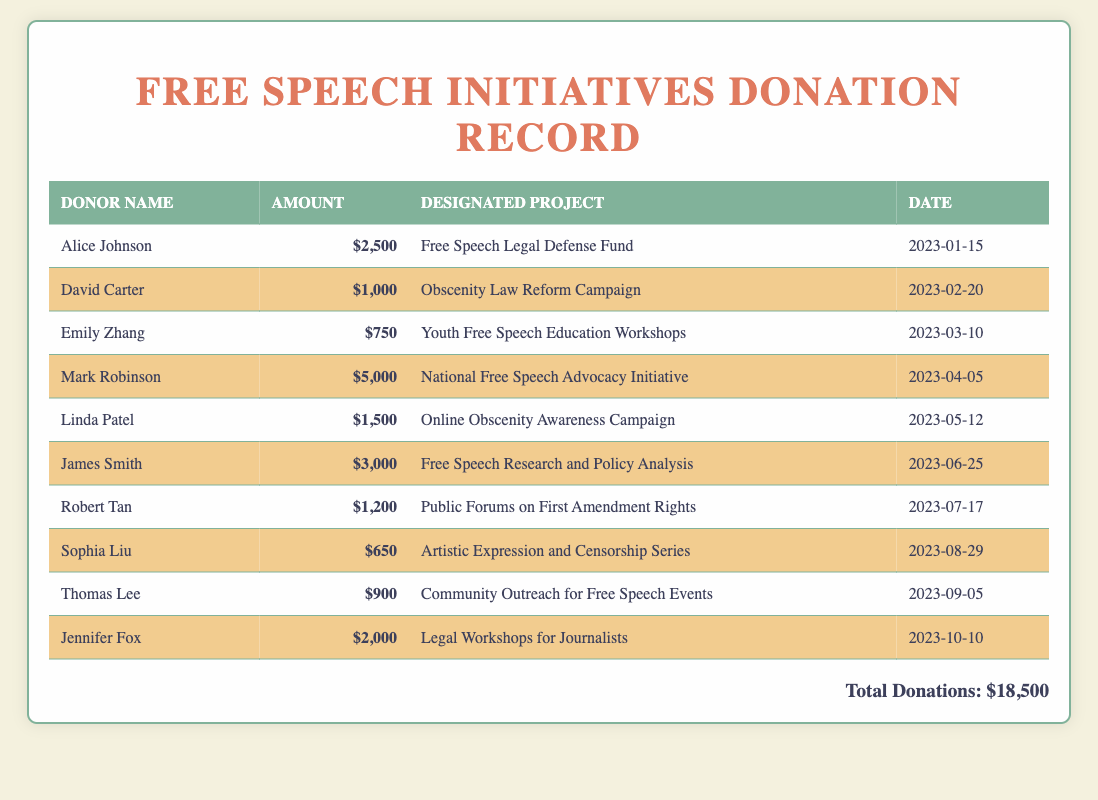What is the total amount of donations received? The total amount of donations is explicitly stated at the bottom of the document.
Answer: $18,500 Who is the donor for the "National Free Speech Advocacy Initiative"? The name of the donor for this specific project is provided in the donation table.
Answer: Mark Robinson What amount was donated by Emily Zhang? The donation amount made by Emily Zhang is specified in the document.
Answer: $750 Which project received the most funding? The project with the highest amount of funding can be inferred from comparing the donation amounts in the table.
Answer: National Free Speech Advocacy Initiative How many donors contributed more than $1,000? This requires counting the donors with contributions that exceed $1,000 from the table data.
Answer: 4 On what date was the "Online Obscenity Awareness Campaign" donation received? The specific date of the donation for this project is included in the document.
Answer: 2023-05-12 Which project was supported by the largest single donation? The answer requires identifying which project corresponds to the highest single donation amount in the table.
Answer: National Free Speech Advocacy Initiative How many projects received donations of $1,000 or more? This involves counting the number of projects listed that received donations above the specified threshold.
Answer: 5 